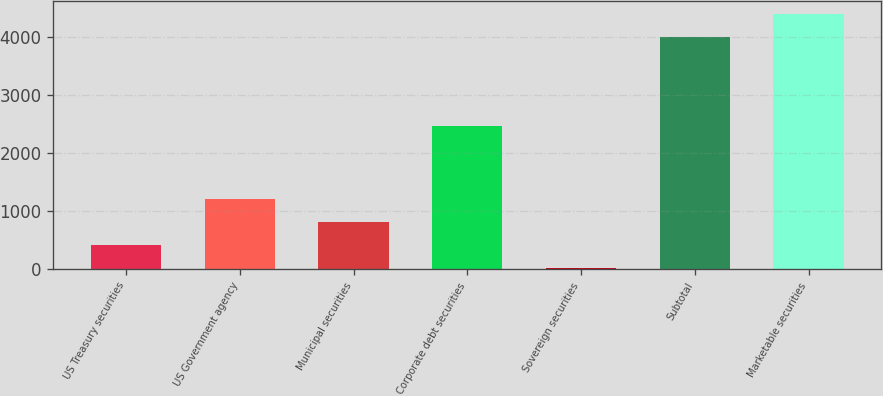Convert chart to OTSL. <chart><loc_0><loc_0><loc_500><loc_500><bar_chart><fcel>US Treasury securities<fcel>US Government agency<fcel>Municipal securities<fcel>Corporate debt securities<fcel>Sovereign securities<fcel>Subtotal<fcel>Marketable securities<nl><fcel>417.3<fcel>1213.9<fcel>815.6<fcel>2466<fcel>19<fcel>4002<fcel>4400.3<nl></chart> 